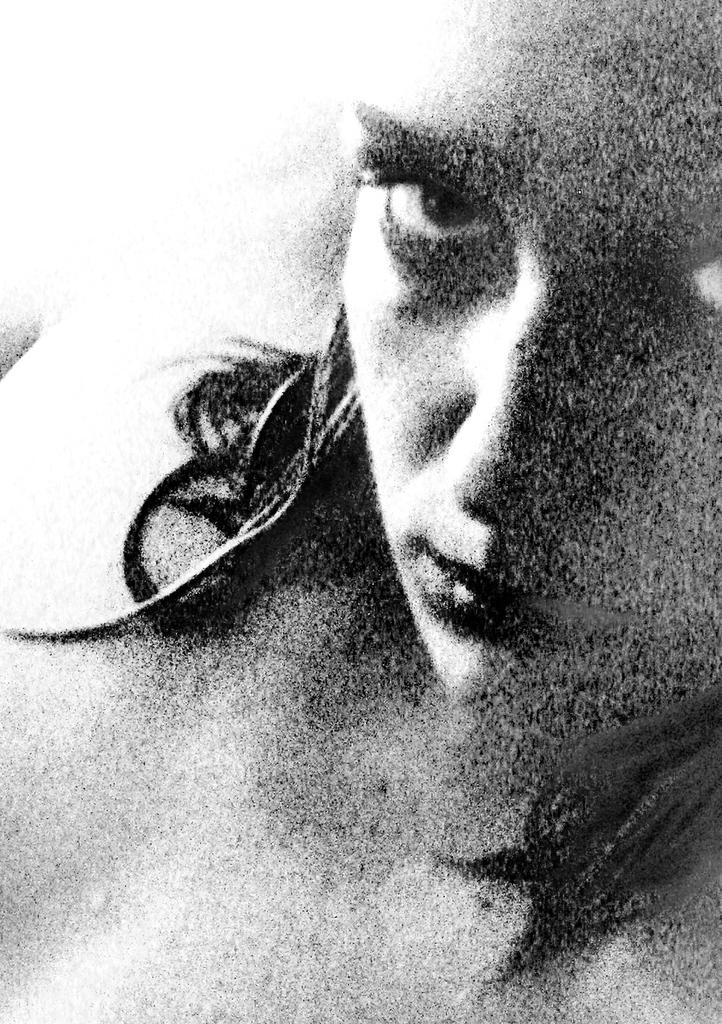What is the color scheme of the picture? The picture is black and white. Can you describe the main subject in the image? There is a person in the picture. Where is the unit located in the picture? There is no unit present in the image. What type of crate is being used by the person in the picture? There is no crate visible in the image. 